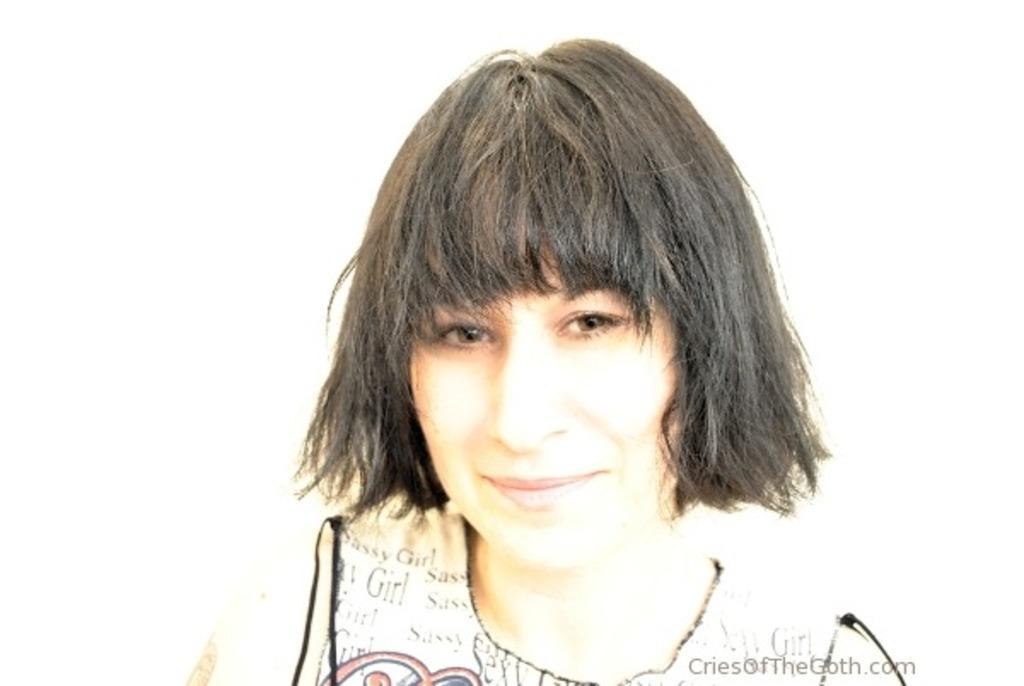Please provide a concise description of this image. In the center of the image we can see the woman smiling and the background is in white color. In the bottom right corner we can see the text. 